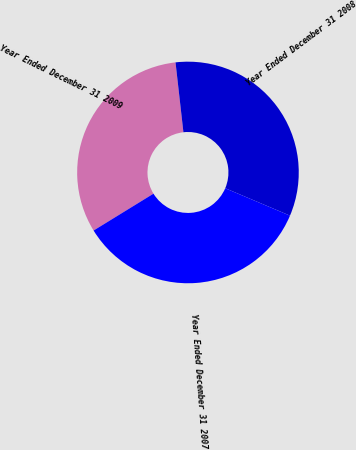Convert chart to OTSL. <chart><loc_0><loc_0><loc_500><loc_500><pie_chart><fcel>Year Ended December 31 2009<fcel>Year Ended December 31 2008<fcel>Year Ended December 31 2007<nl><fcel>31.99%<fcel>33.16%<fcel>34.85%<nl></chart> 